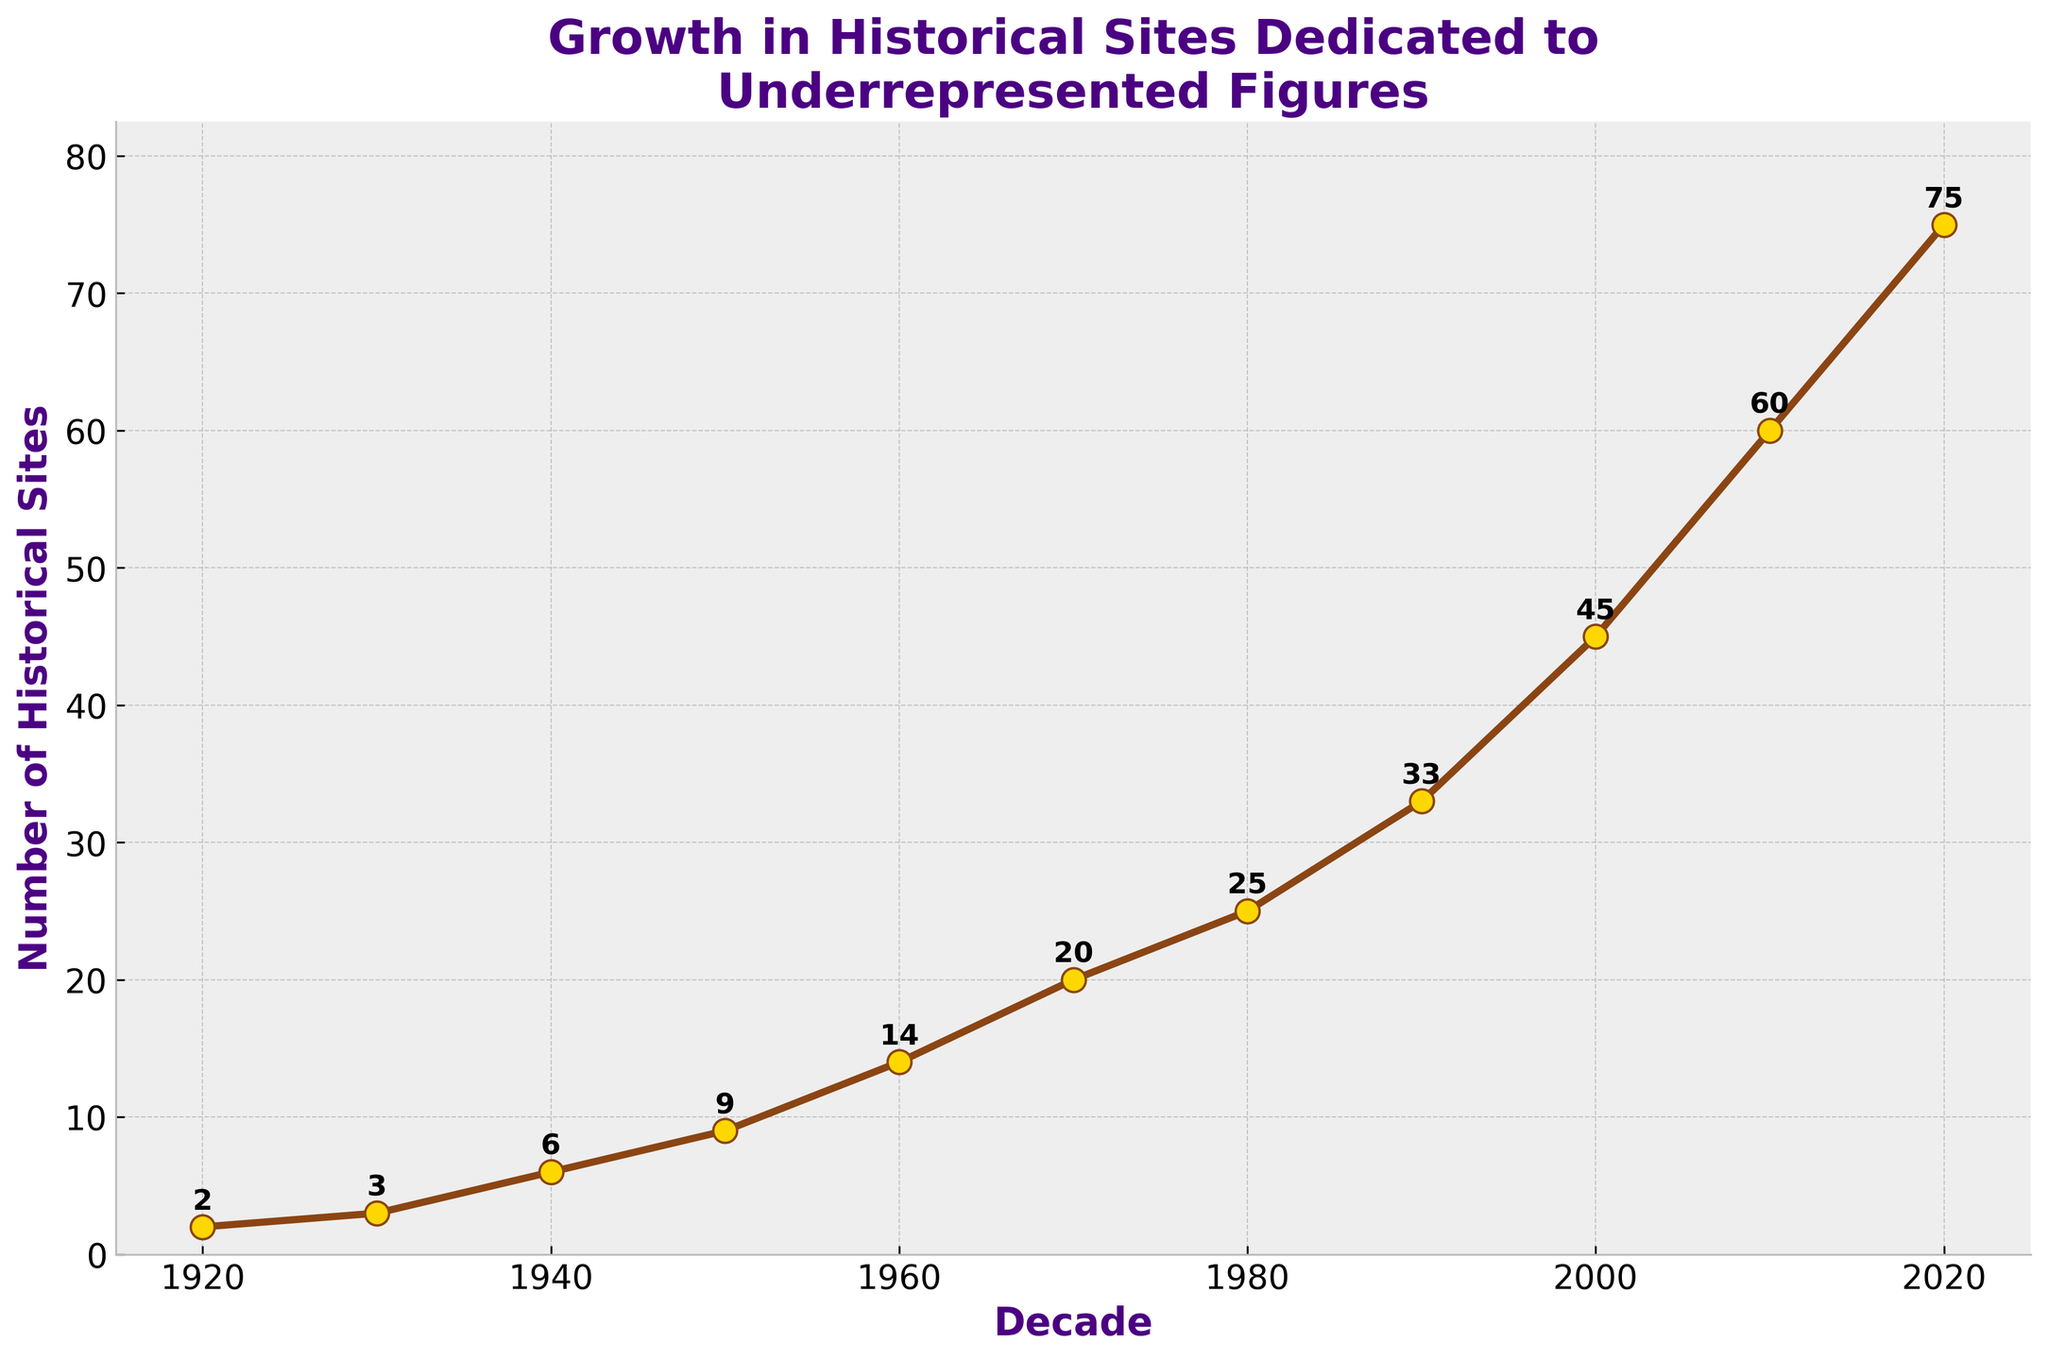What's the title of the plot? The title of the plot is located at the top center of the figure. It describes the overall theme or subject of the data presented.
Answer: Growth in Historical Sites Dedicated to Underrepresented Figures What's the count of historical sites in the 1950s? Locate the decade "1950" on the x-axis and find the corresponding y-value. Annotate it from the plot.
Answer: 9 What is the difference in the number of historical sites between 1980 and 2000? Locate the values for the years 1980 and 2000 on the y-axis, then calculate the difference: 45 (2000) - 25 (1980) = 20.
Answer: 20 How has the number of historical sites changed from 1960 to 1970? Find the values corresponding to the years 1960 and 1970, and calculate their difference: 20 (1970) - 14 (1960) = 6 and note if it increased or decreased.
Answer: Increased by 6 Which decade saw the highest growth in the number of historical sites? Calculate the difference in the number of sites for each decade, and find the largest difference. The decade with the highest growth is 2010 to 2020: 75 (2020) - 60 (2010) = 15.
Answer: 2010 to 2020 What is the average number of historical sites created per decade? Sum the number of historical sites for each decade and divide by the number of decades. (2+3+6+9+14+20+25+33+45+60+75)/11 = 26.64.
Answer: 26.64 How many more historical sites were there in 2020 compared to 1920? Locate the values for 2020 and 1920, and subtract the latter from the former: 75 (2020) - 2 (1920) = 73.
Answer: 73 Between which two consecutive decades was the increase in historical sites the smallest? Calculate the difference for each pair of consecutive decades, and identify the smallest difference. The smallest is between 1930 and 1940: 6 (1940) - 3 (1930) = 3.
Answer: 1930 to 1940 